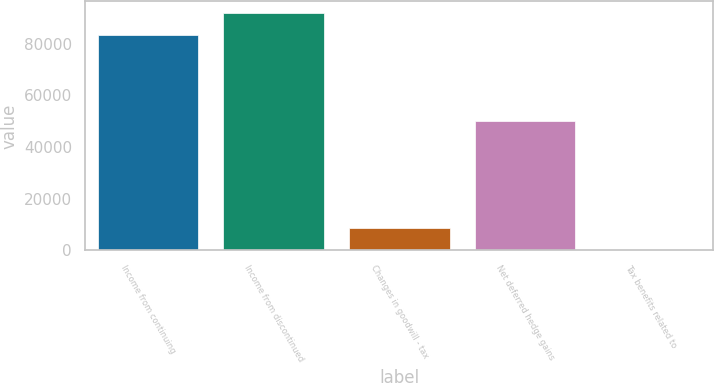Convert chart. <chart><loc_0><loc_0><loc_500><loc_500><bar_chart><fcel>Income from continuing<fcel>Income from discontinued<fcel>Changes in goodwill - tax<fcel>Net deferred hedge gains<fcel>Tax benefits related to<nl><fcel>83195<fcel>91747.6<fcel>8553.6<fcel>50059<fcel>1<nl></chart> 